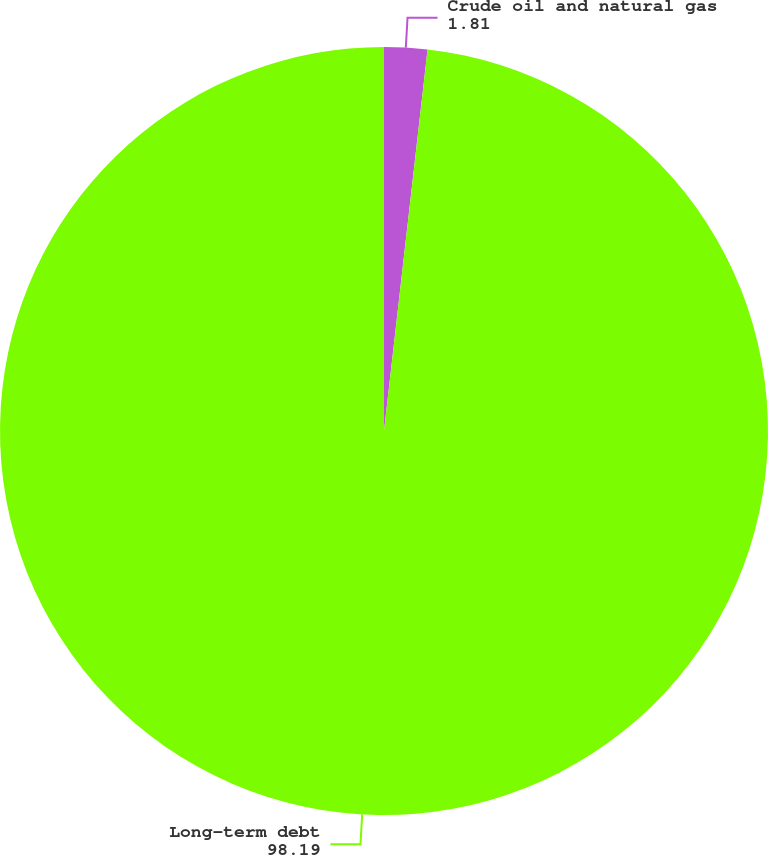Convert chart. <chart><loc_0><loc_0><loc_500><loc_500><pie_chart><fcel>Crude oil and natural gas<fcel>Long-term debt<nl><fcel>1.81%<fcel>98.19%<nl></chart> 